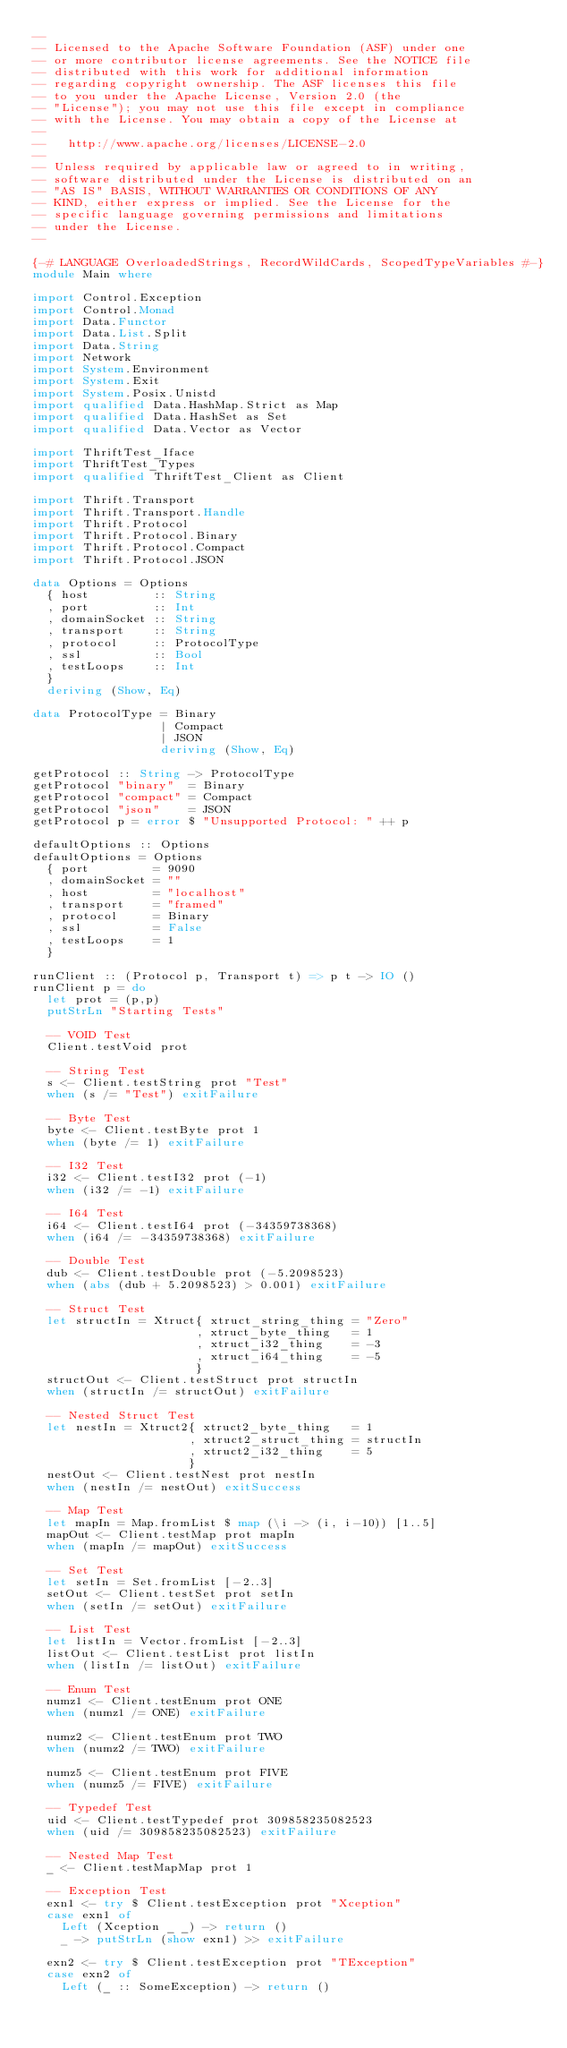<code> <loc_0><loc_0><loc_500><loc_500><_Haskell_>--
-- Licensed to the Apache Software Foundation (ASF) under one
-- or more contributor license agreements. See the NOTICE file
-- distributed with this work for additional information
-- regarding copyright ownership. The ASF licenses this file
-- to you under the Apache License, Version 2.0 (the
-- "License"); you may not use this file except in compliance
-- with the License. You may obtain a copy of the License at
--
--   http://www.apache.org/licenses/LICENSE-2.0
--
-- Unless required by applicable law or agreed to in writing,
-- software distributed under the License is distributed on an
-- "AS IS" BASIS, WITHOUT WARRANTIES OR CONDITIONS OF ANY
-- KIND, either express or implied. See the License for the
-- specific language governing permissions and limitations
-- under the License.
--

{-# LANGUAGE OverloadedStrings, RecordWildCards, ScopedTypeVariables #-}
module Main where

import Control.Exception
import Control.Monad
import Data.Functor
import Data.List.Split
import Data.String
import Network
import System.Environment
import System.Exit
import System.Posix.Unistd
import qualified Data.HashMap.Strict as Map
import qualified Data.HashSet as Set
import qualified Data.Vector as Vector

import ThriftTest_Iface
import ThriftTest_Types
import qualified ThriftTest_Client as Client

import Thrift.Transport
import Thrift.Transport.Handle
import Thrift.Protocol
import Thrift.Protocol.Binary
import Thrift.Protocol.Compact
import Thrift.Protocol.JSON

data Options = Options
  { host         :: String
  , port         :: Int
  , domainSocket :: String
  , transport    :: String
  , protocol     :: ProtocolType
  , ssl          :: Bool
  , testLoops    :: Int
  }
  deriving (Show, Eq)

data ProtocolType = Binary
                  | Compact
                  | JSON
                  deriving (Show, Eq)

getProtocol :: String -> ProtocolType
getProtocol "binary"  = Binary
getProtocol "compact" = Compact
getProtocol "json"    = JSON
getProtocol p = error $ "Unsupported Protocol: " ++ p

defaultOptions :: Options
defaultOptions = Options
  { port         = 9090
  , domainSocket = ""
  , host         = "localhost"
  , transport    = "framed"
  , protocol     = Binary
  , ssl          = False
  , testLoops    = 1
  }

runClient :: (Protocol p, Transport t) => p t -> IO ()
runClient p = do
  let prot = (p,p)
  putStrLn "Starting Tests"

  -- VOID Test
  Client.testVoid prot

  -- String Test
  s <- Client.testString prot "Test"
  when (s /= "Test") exitFailure

  -- Byte Test
  byte <- Client.testByte prot 1
  when (byte /= 1) exitFailure

  -- I32 Test
  i32 <- Client.testI32 prot (-1)
  when (i32 /= -1) exitFailure

  -- I64 Test
  i64 <- Client.testI64 prot (-34359738368)
  when (i64 /= -34359738368) exitFailure

  -- Double Test
  dub <- Client.testDouble prot (-5.2098523)
  when (abs (dub + 5.2098523) > 0.001) exitFailure

  -- Struct Test
  let structIn = Xtruct{ xtruct_string_thing = "Zero"
                       , xtruct_byte_thing   = 1
                       , xtruct_i32_thing    = -3
                       , xtruct_i64_thing    = -5
                       }
  structOut <- Client.testStruct prot structIn
  when (structIn /= structOut) exitFailure

  -- Nested Struct Test
  let nestIn = Xtruct2{ xtruct2_byte_thing   = 1
                      , xtruct2_struct_thing = structIn
                      , xtruct2_i32_thing    = 5
                      }
  nestOut <- Client.testNest prot nestIn
  when (nestIn /= nestOut) exitSuccess

  -- Map Test
  let mapIn = Map.fromList $ map (\i -> (i, i-10)) [1..5]
  mapOut <- Client.testMap prot mapIn
  when (mapIn /= mapOut) exitSuccess

  -- Set Test
  let setIn = Set.fromList [-2..3]
  setOut <- Client.testSet prot setIn
  when (setIn /= setOut) exitFailure

  -- List Test
  let listIn = Vector.fromList [-2..3]
  listOut <- Client.testList prot listIn
  when (listIn /= listOut) exitFailure

  -- Enum Test
  numz1 <- Client.testEnum prot ONE
  when (numz1 /= ONE) exitFailure

  numz2 <- Client.testEnum prot TWO
  when (numz2 /= TWO) exitFailure

  numz5 <- Client.testEnum prot FIVE
  when (numz5 /= FIVE) exitFailure

  -- Typedef Test
  uid <- Client.testTypedef prot 309858235082523
  when (uid /= 309858235082523) exitFailure

  -- Nested Map Test
  _ <- Client.testMapMap prot 1

  -- Exception Test
  exn1 <- try $ Client.testException prot "Xception"
  case exn1 of
    Left (Xception _ _) -> return ()
    _ -> putStrLn (show exn1) >> exitFailure

  exn2 <- try $ Client.testException prot "TException"
  case exn2 of
    Left (_ :: SomeException) -> return ()</code> 